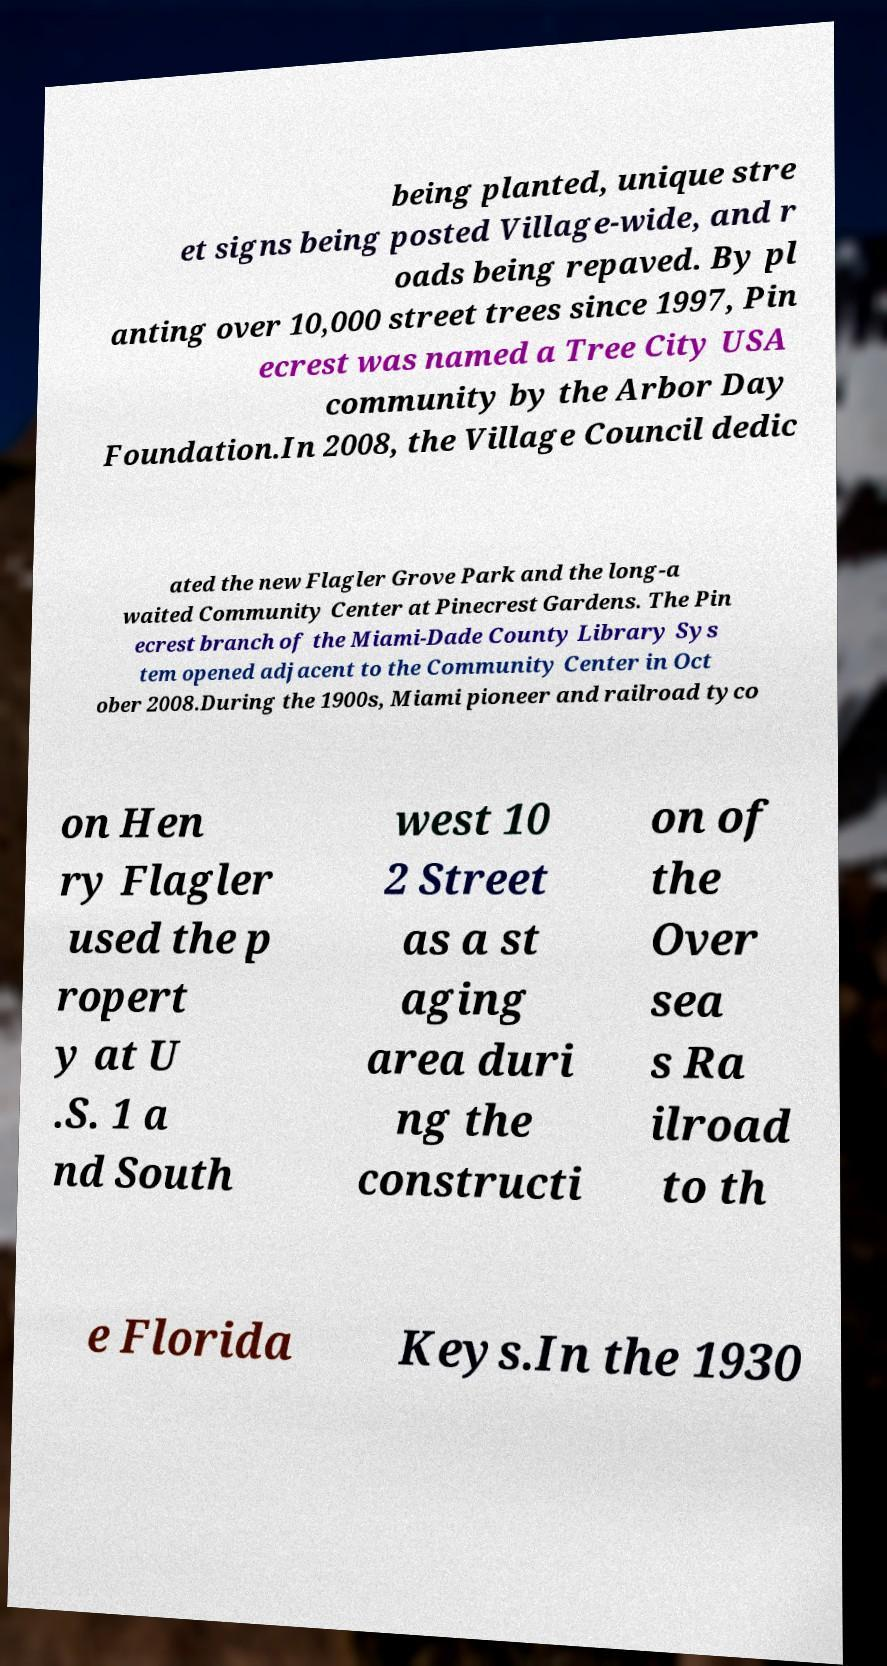There's text embedded in this image that I need extracted. Can you transcribe it verbatim? being planted, unique stre et signs being posted Village-wide, and r oads being repaved. By pl anting over 10,000 street trees since 1997, Pin ecrest was named a Tree City USA community by the Arbor Day Foundation.In 2008, the Village Council dedic ated the new Flagler Grove Park and the long-a waited Community Center at Pinecrest Gardens. The Pin ecrest branch of the Miami-Dade County Library Sys tem opened adjacent to the Community Center in Oct ober 2008.During the 1900s, Miami pioneer and railroad tyco on Hen ry Flagler used the p ropert y at U .S. 1 a nd South west 10 2 Street as a st aging area duri ng the constructi on of the Over sea s Ra ilroad to th e Florida Keys.In the 1930 